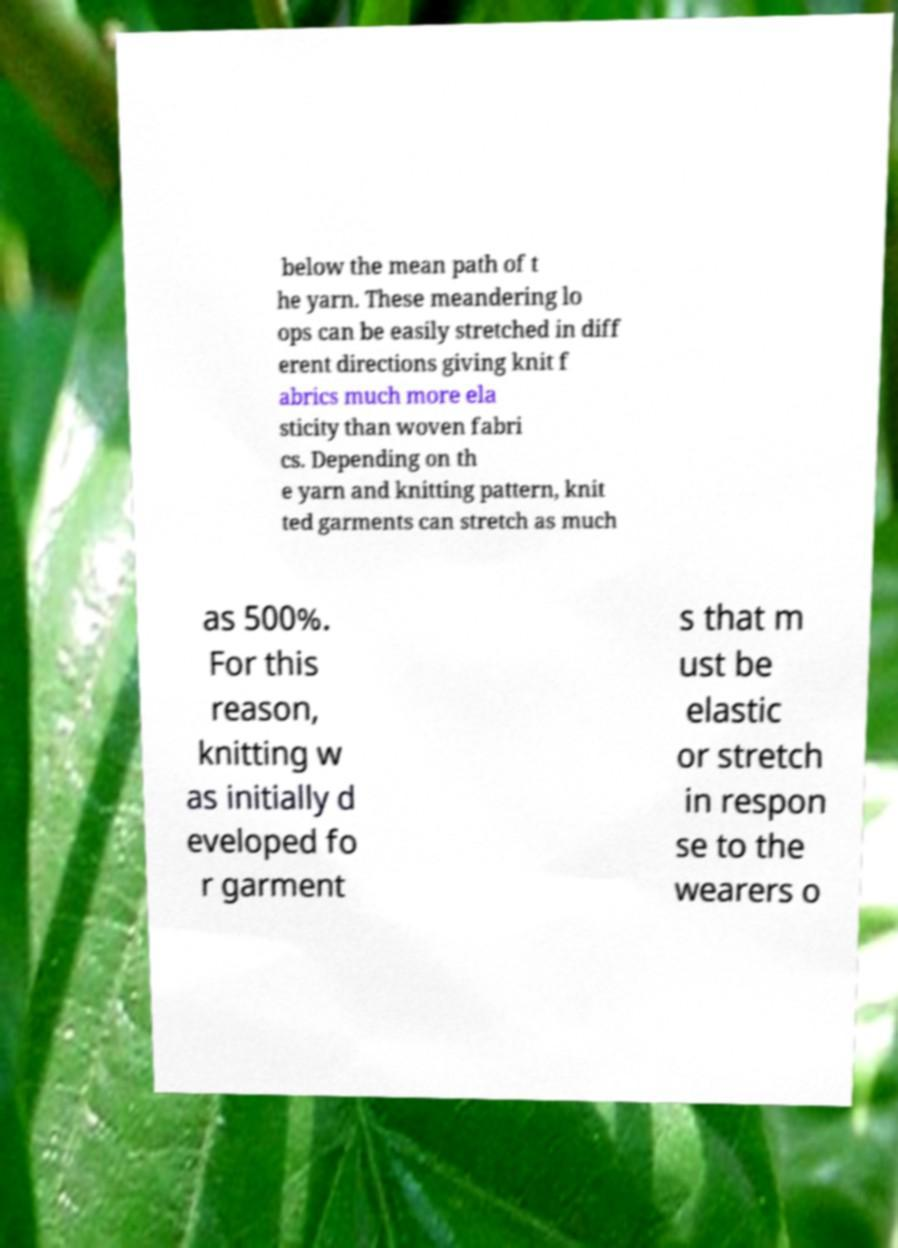What messages or text are displayed in this image? I need them in a readable, typed format. below the mean path of t he yarn. These meandering lo ops can be easily stretched in diff erent directions giving knit f abrics much more ela sticity than woven fabri cs. Depending on th e yarn and knitting pattern, knit ted garments can stretch as much as 500%. For this reason, knitting w as initially d eveloped fo r garment s that m ust be elastic or stretch in respon se to the wearers o 